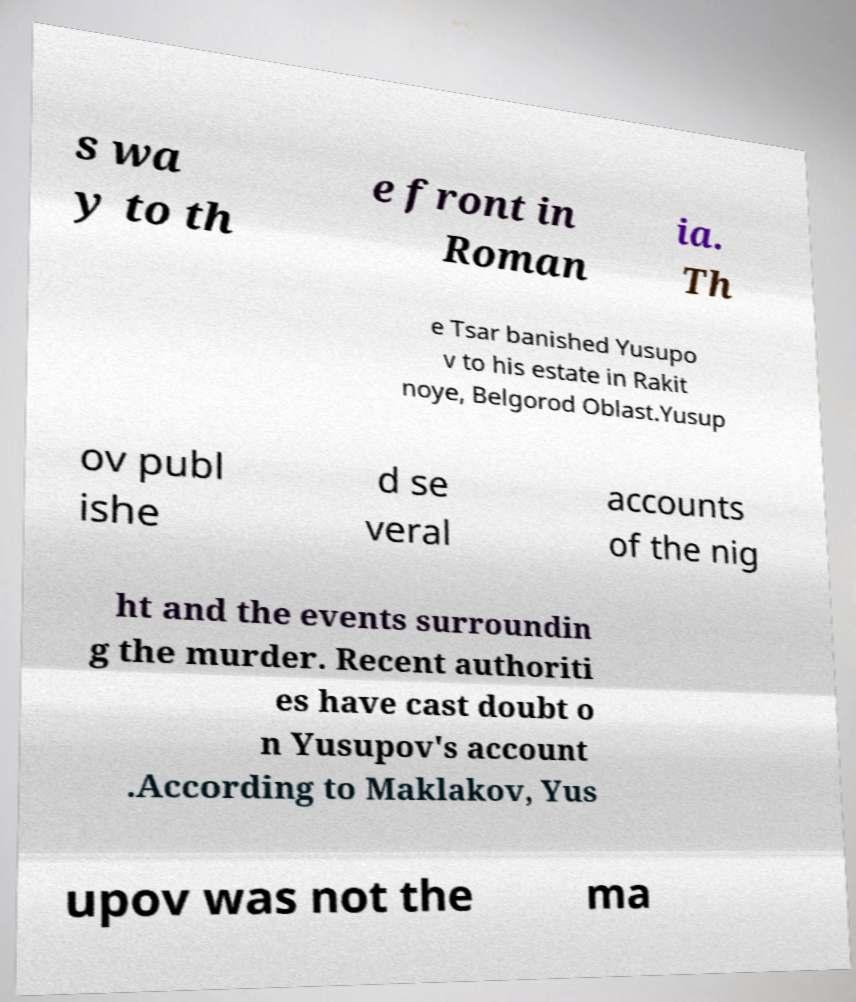Could you extract and type out the text from this image? s wa y to th e front in Roman ia. Th e Tsar banished Yusupo v to his estate in Rakit noye, Belgorod Oblast.Yusup ov publ ishe d se veral accounts of the nig ht and the events surroundin g the murder. Recent authoriti es have cast doubt o n Yusupov's account .According to Maklakov, Yus upov was not the ma 